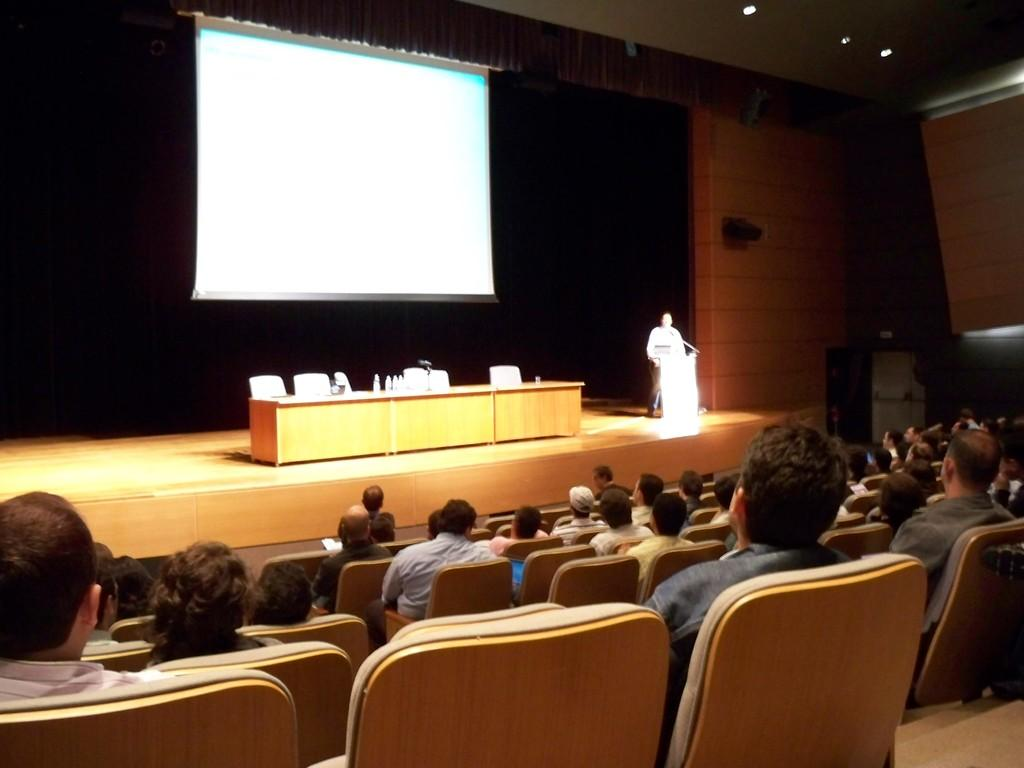What are the people in the image doing? The persons sitting on chairs in the image are likely attending an event or presentation. What is the man in the image doing? The man standing in front of a podium in the image is likely giving a speech or presentation. What device is used to display visuals in the image? A projector is present in the image to display visuals. What type of covering is present in the image? There is a curtain in the image. What type of summer clothing is the man wearing in the image? There is no mention of summer clothing or the season in the image, and the man is wearing a suit while standing at a podium. What is the grandmother doing in the image? There is no mention of a grandmother or any elderly person in the image. 